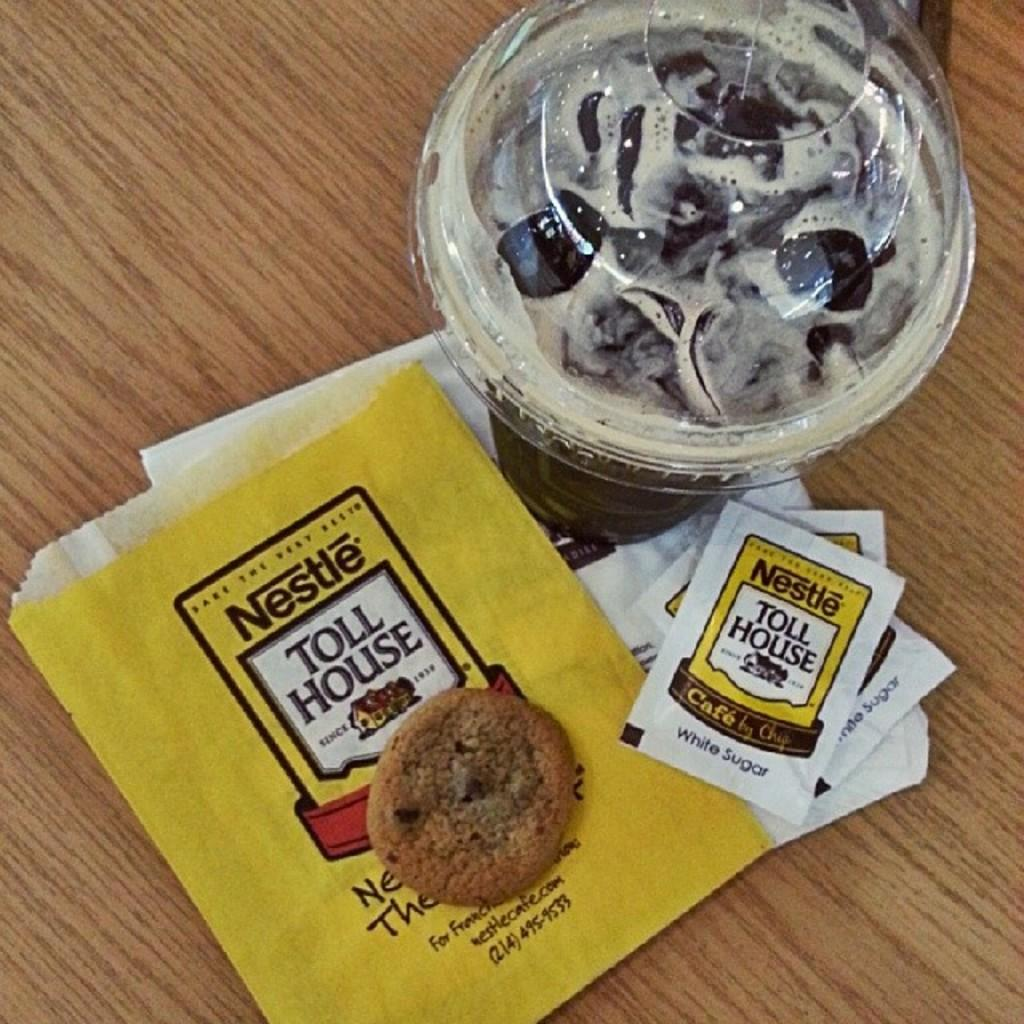What piece of furniture is present in the image? There is a table in the image. What is placed on the table? There is a coffee cup, sugar packets, and a cookie on the table. Can you describe the coffee cup in the image? The coffee cup is on the table. What type of root can be seen growing from the coffee cup in the image? There is no root growing from the coffee cup in the image. 